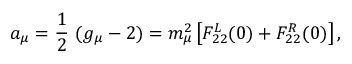Convert formula to latex. <formula><loc_0><loc_0><loc_500><loc_500>a _ { \mu } = { \frac { 1 } { 2 } } ( g _ { \mu } - 2 ) = m _ { \mu } ^ { 2 } \left [ F _ { 2 2 } ^ { L } ( 0 ) + F _ { 2 2 } ^ { R } ( 0 ) \right ] ,</formula> 